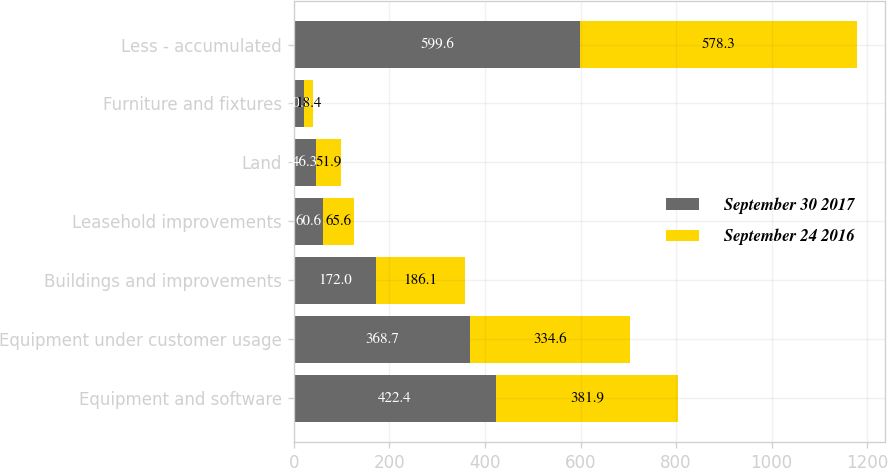<chart> <loc_0><loc_0><loc_500><loc_500><stacked_bar_chart><ecel><fcel>Equipment and software<fcel>Equipment under customer usage<fcel>Buildings and improvements<fcel>Leasehold improvements<fcel>Land<fcel>Furniture and fixtures<fcel>Less - accumulated<nl><fcel>September 30 2017<fcel>422.4<fcel>368.7<fcel>172<fcel>60.6<fcel>46.3<fcel>20.8<fcel>599.6<nl><fcel>September 24 2016<fcel>381.9<fcel>334.6<fcel>186.1<fcel>65.6<fcel>51.9<fcel>18.4<fcel>578.3<nl></chart> 